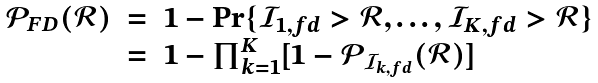<formula> <loc_0><loc_0><loc_500><loc_500>\begin{array} { l l l } \mathcal { P } _ { F D } ( \mathcal { R } ) & = & 1 - \Pr \{ \mathcal { I } _ { 1 , f d } > \mathcal { R } , \dots , \mathcal { I } _ { K , f d } > \mathcal { R } \} \\ & = & 1 - \prod _ { k = 1 } ^ { K } [ 1 - \mathcal { P } _ { \mathcal { I } _ { k , f d } } ( \mathcal { R } ) ] \end{array}</formula> 